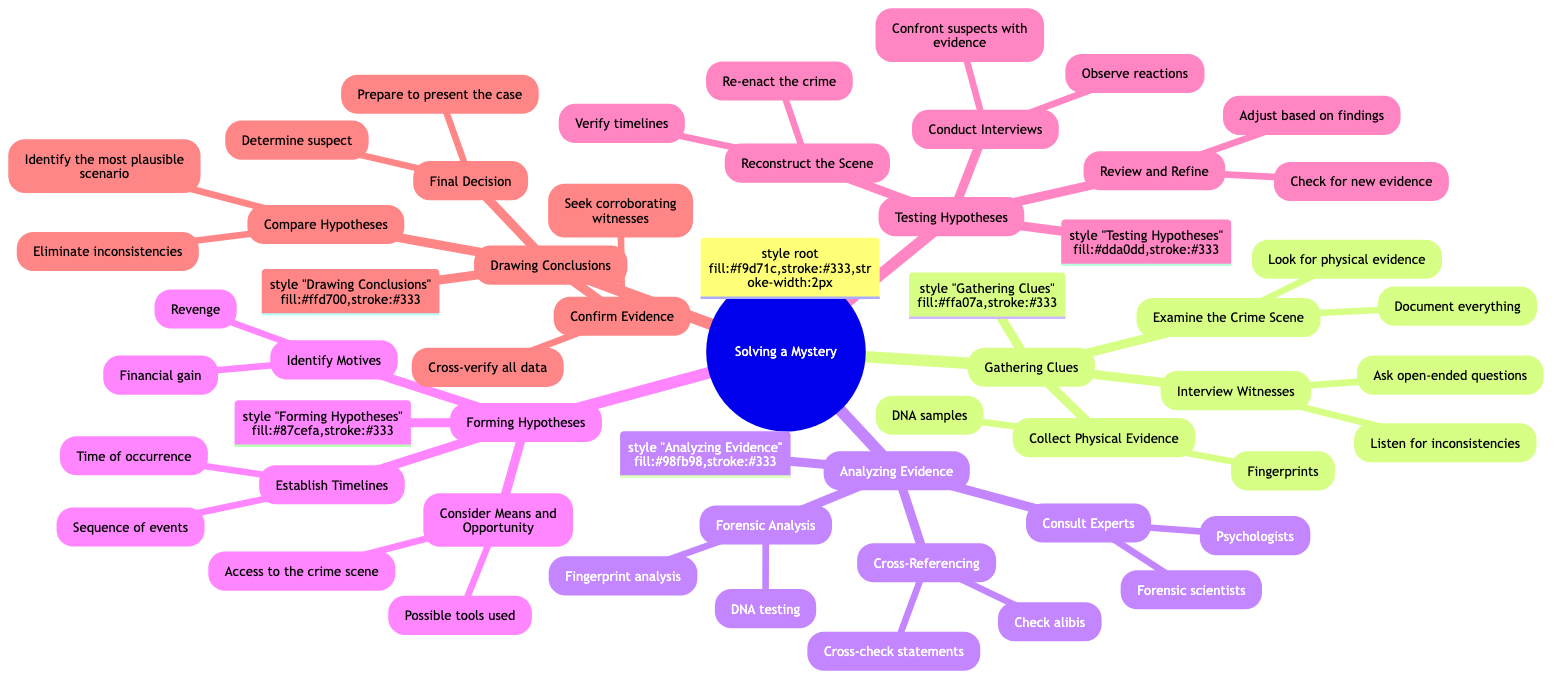What is the first step in solving a mystery? The first step, as indicated in the mind map, is "Gathering Clues." This is the leading node under the main topic of "Solving a Mystery."
Answer: Gathering Clues How many main steps are there in the mystery-solving process? By counting the main categories listed under the "Solving a Mystery" node, we find there are five main steps: Gathering Clues, Analyzing Evidence, Forming Hypotheses, Testing Hypotheses, and Drawing Conclusions.
Answer: 5 Which step includes "Cross-check statements"? "Cross-check statements" is found under the "Analyzing Evidence" category, which details methods for analyzing evidence gathered during the investigation.
Answer: Analyzing Evidence What must you do during the "Final Decision" stage? During the "Final Decision" stage, one must "Determine suspect" and "Prepare to present the case," both of which are the final actions in concluding the investigation.
Answer: Determine suspect, Prepare to present the case What are the three methods listed under "Testing Hypotheses"? The three methods listed under "Testing Hypotheses" include "Conduct Interviews," "Reconstruct the Scene," and "Review and Refine." These represent various approaches to validate or challenge the hypotheses formed earlier in the investigation.
Answer: Conduct Interviews, Reconstruct the Scene, Review and Refine What does "Consult Experts" refer to in the process? "Consult Experts," located within the "Analyzing Evidence" section, refers to seeking guidance from individuals with specialized knowledge, such as forensic scientists and psychologists, to aid in understanding the evidence and the context of the crime.
Answer: Forensic scientists, Psychologists Which hypothesis involves assessing "Possible tools used"? The hypothesis that involves assessing "Possible tools used" is categorized under "Consider Means and Opportunity," which is part of the "Forming Hypotheses" step focused on understanding how the crime could have been carried out.
Answer: Consider Means and Opportunity What type of questions should be asked while "Interviewing Witnesses"? While "Interviewing Witnesses," one should ask "open-ended questions" and "Listen for inconsistencies," both of which are important for gathering detailed information and identifying potential contradictions in witness statements.
Answer: Open-ended questions, Listen for inconsistencies 